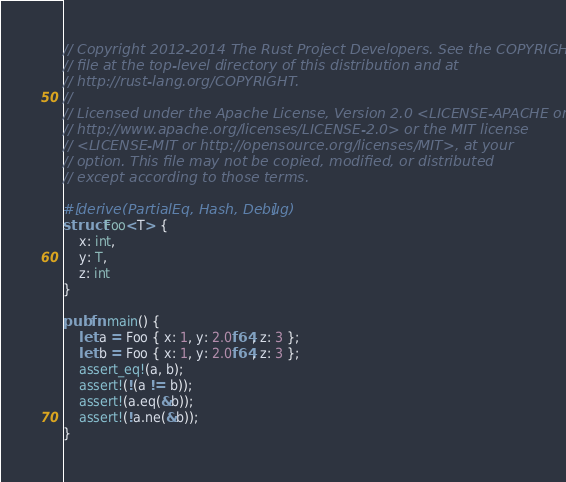Convert code to text. <code><loc_0><loc_0><loc_500><loc_500><_Rust_>// Copyright 2012-2014 The Rust Project Developers. See the COPYRIGHT
// file at the top-level directory of this distribution and at
// http://rust-lang.org/COPYRIGHT.
//
// Licensed under the Apache License, Version 2.0 <LICENSE-APACHE or
// http://www.apache.org/licenses/LICENSE-2.0> or the MIT license
// <LICENSE-MIT or http://opensource.org/licenses/MIT>, at your
// option. This file may not be copied, modified, or distributed
// except according to those terms.

#[derive(PartialEq, Hash, Debug)]
struct Foo<T> {
    x: int,
    y: T,
    z: int
}

pub fn main() {
    let a = Foo { x: 1, y: 2.0f64, z: 3 };
    let b = Foo { x: 1, y: 2.0f64, z: 3 };
    assert_eq!(a, b);
    assert!(!(a != b));
    assert!(a.eq(&b));
    assert!(!a.ne(&b));
}
</code> 